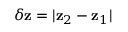Convert formula to latex. <formula><loc_0><loc_0><loc_500><loc_500>\delta z = | z _ { 2 } - z _ { 1 } |</formula> 